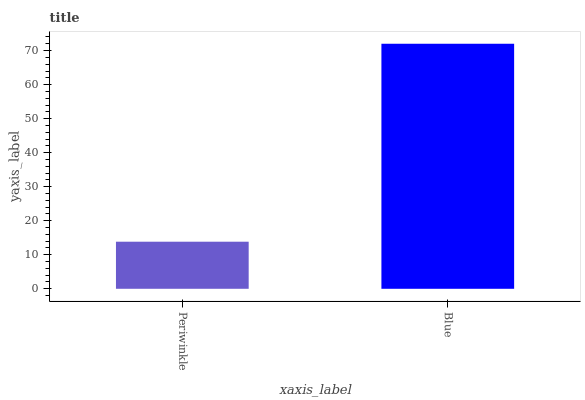Is Blue the minimum?
Answer yes or no. No. Is Blue greater than Periwinkle?
Answer yes or no. Yes. Is Periwinkle less than Blue?
Answer yes or no. Yes. Is Periwinkle greater than Blue?
Answer yes or no. No. Is Blue less than Periwinkle?
Answer yes or no. No. Is Blue the high median?
Answer yes or no. Yes. Is Periwinkle the low median?
Answer yes or no. Yes. Is Periwinkle the high median?
Answer yes or no. No. Is Blue the low median?
Answer yes or no. No. 